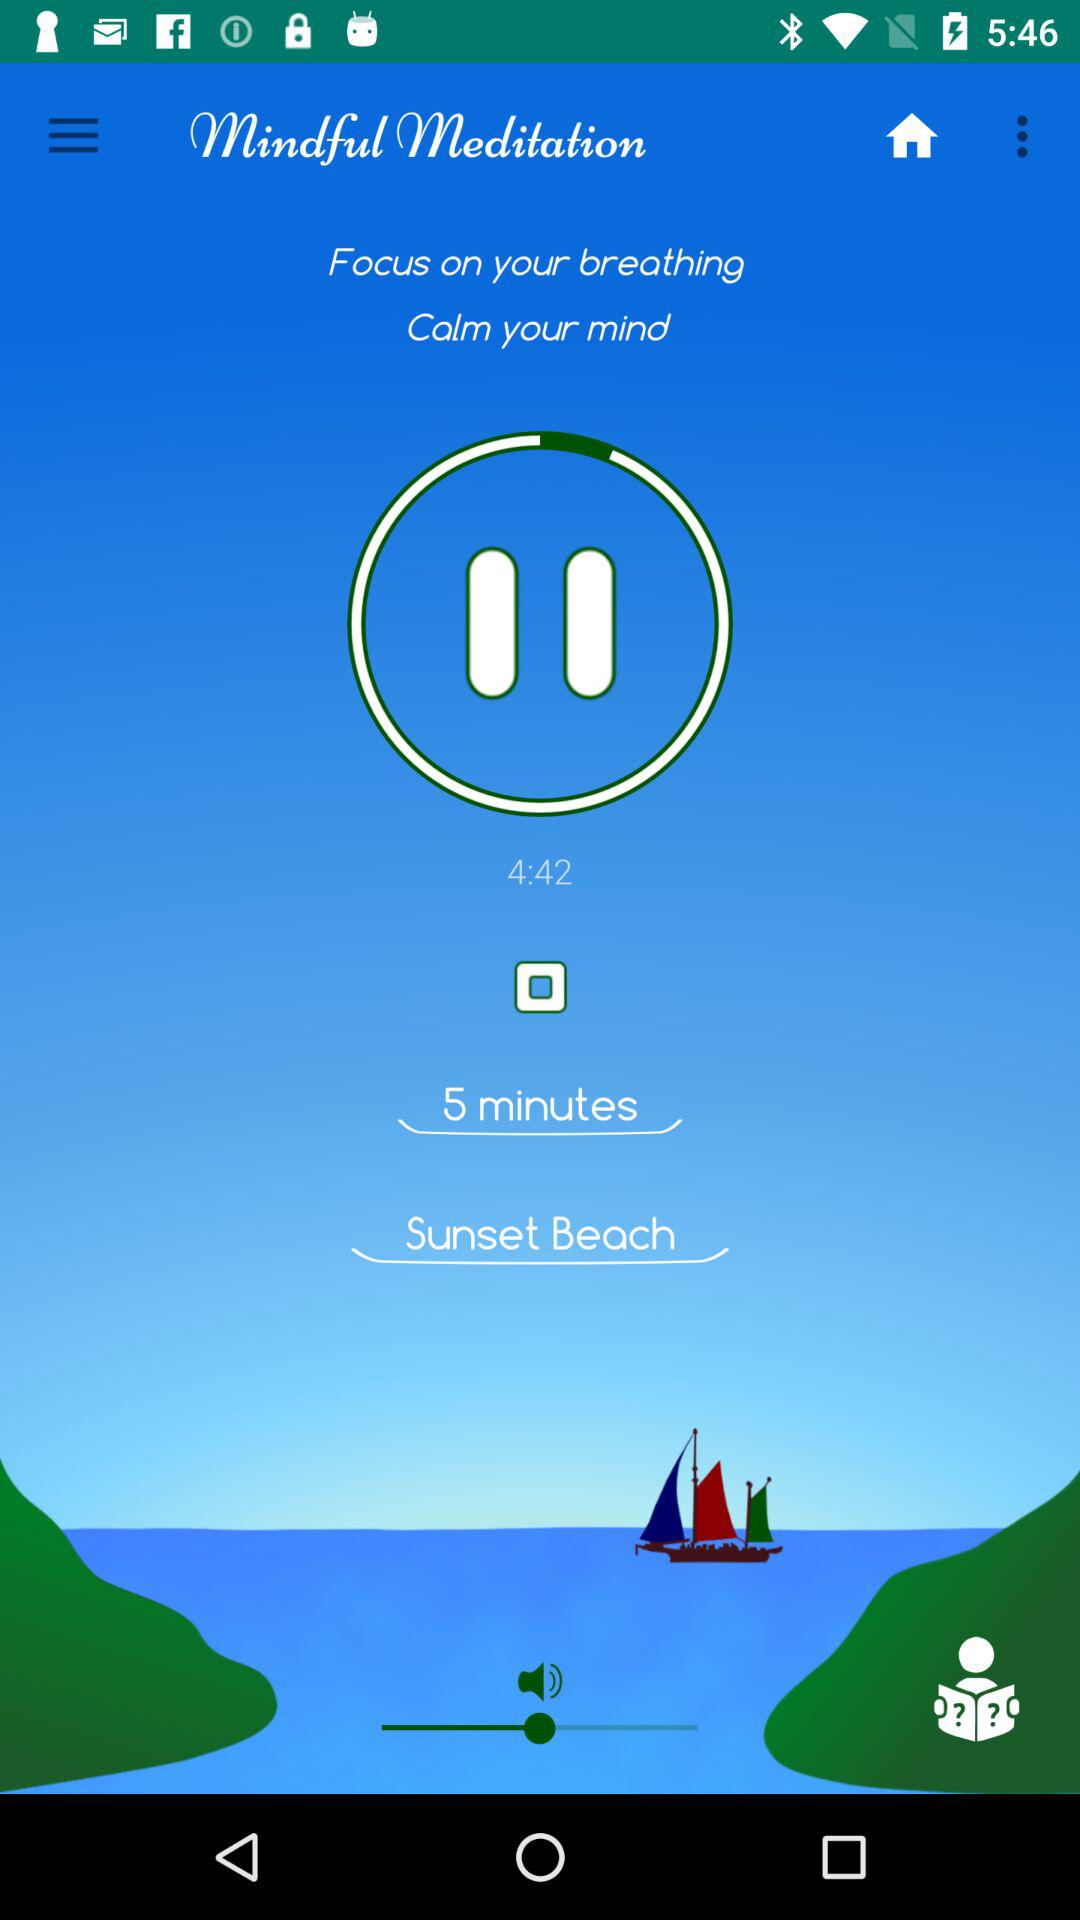What are the instructions given in "Mindful Meditation"? The given instructions in "Mindful Meditation" are to "Focus on your breathing" and "Calm your mind". 